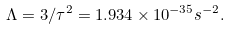<formula> <loc_0><loc_0><loc_500><loc_500>\Lambda = 3 / \tau ^ { 2 } = 1 . 9 3 4 \times 1 0 ^ { - 3 5 } s ^ { - 2 } .</formula> 